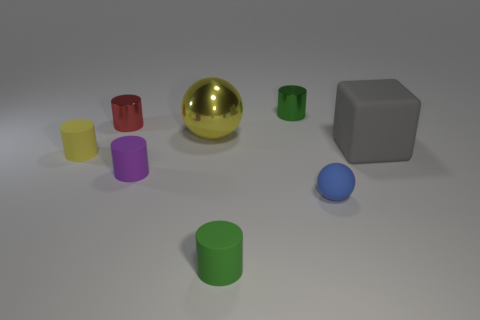Subtract all yellow cylinders. How many cylinders are left? 4 Subtract all small green shiny cylinders. How many cylinders are left? 4 Add 1 large green rubber objects. How many objects exist? 9 Subtract all blue cylinders. Subtract all blue spheres. How many cylinders are left? 5 Subtract all cylinders. How many objects are left? 3 Subtract all rubber spheres. Subtract all tiny yellow rubber objects. How many objects are left? 6 Add 7 small metal cylinders. How many small metal cylinders are left? 9 Add 2 purple cylinders. How many purple cylinders exist? 3 Subtract 0 blue blocks. How many objects are left? 8 